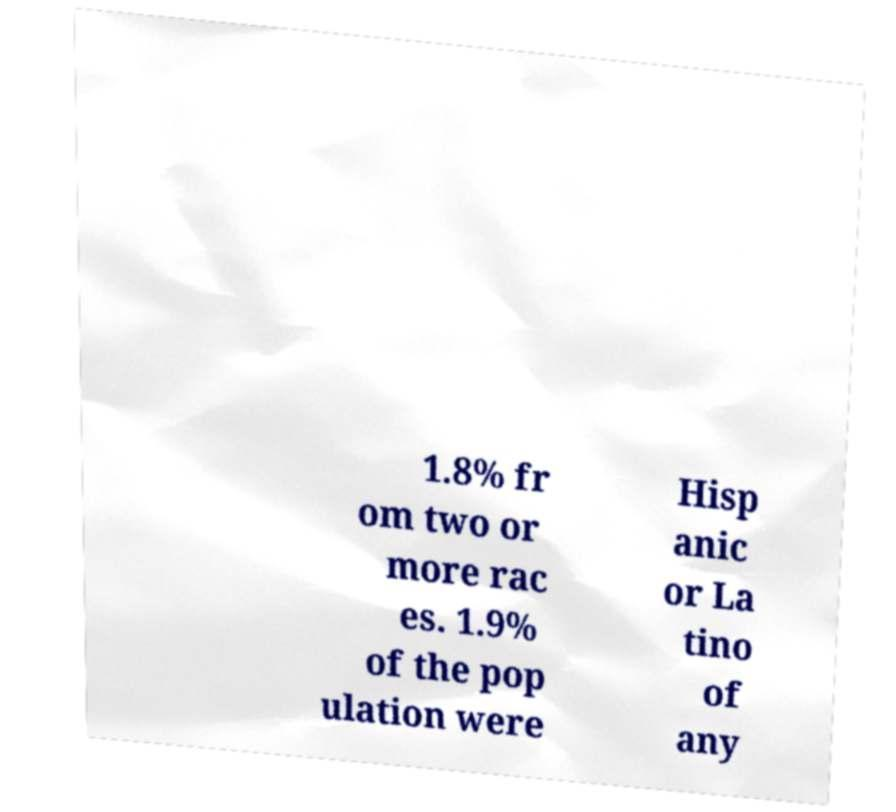I need the written content from this picture converted into text. Can you do that? 1.8% fr om two or more rac es. 1.9% of the pop ulation were Hisp anic or La tino of any 